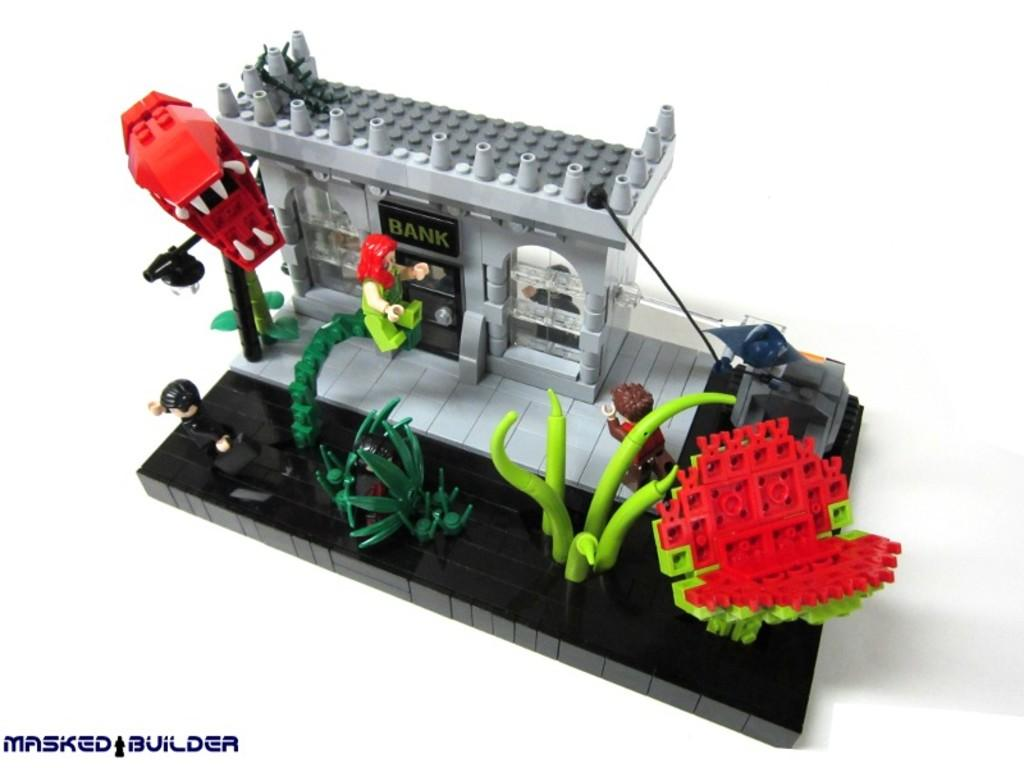What objects are present in the image? There are building blocks in the image. Where is the text located in the image? The text is at the left bottom of the image. What color is the background of the image? The background of the image is white. Can you see any islands in the image? There are no islands present in the image; it features building blocks and text on a white background. 